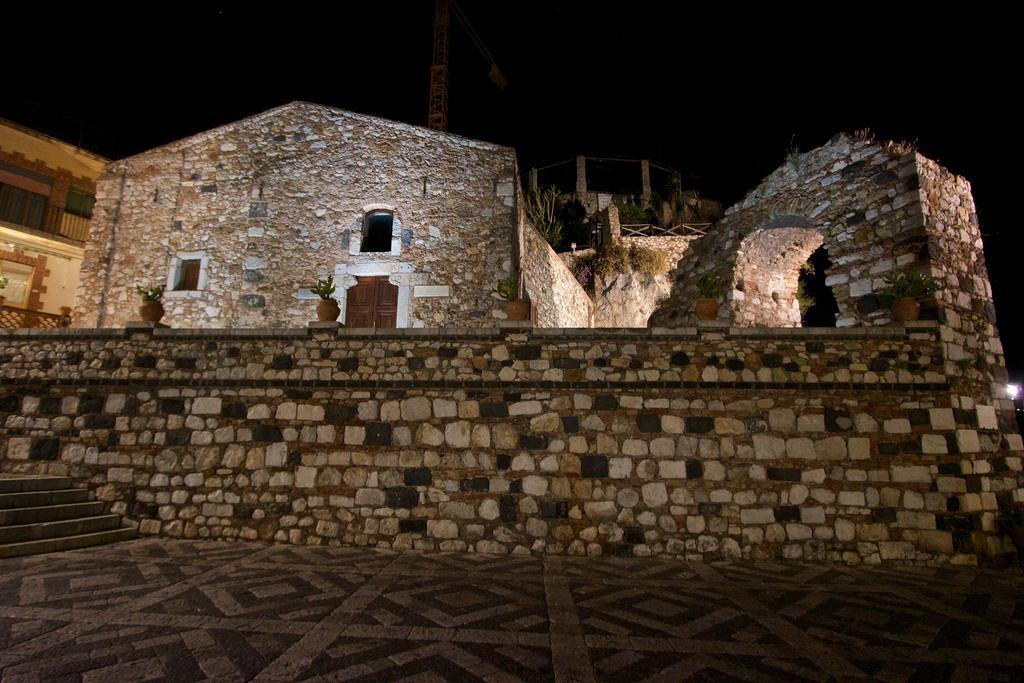How would you summarize this image in a sentence or two? This is an image clicked in the dark. At the bottom, I can see the ground. On the left side there are few stairs. In the middle of the image there is a building and there is a wall. The background is in black color. 